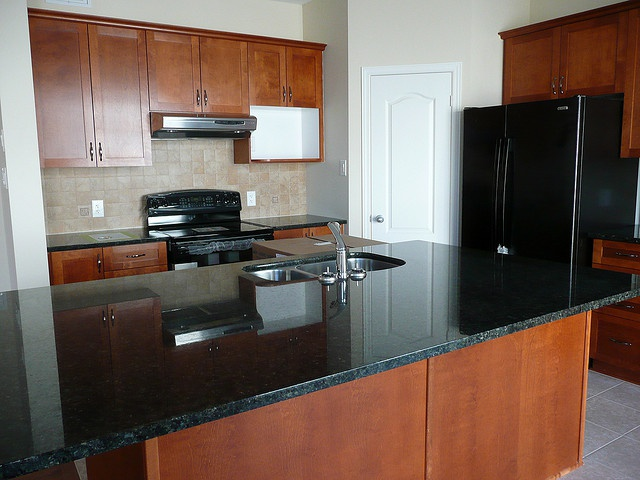Describe the objects in this image and their specific colors. I can see refrigerator in darkgray, black, gray, and maroon tones, oven in darkgray, black, gray, purple, and white tones, and sink in darkgray, gray, black, and purple tones in this image. 